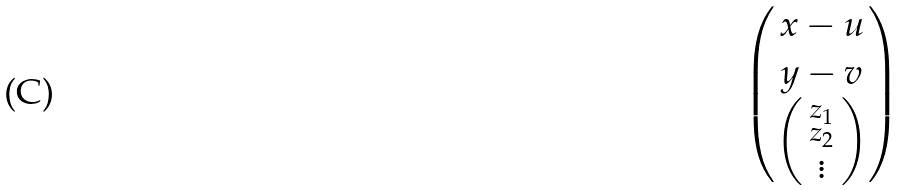Convert formula to latex. <formula><loc_0><loc_0><loc_500><loc_500>\begin{pmatrix} x - u \\ y - v \\ \left ( \begin{smallmatrix} z _ { 1 } \\ z _ { 2 } \\ \vdots \end{smallmatrix} \right ) \end{pmatrix}</formula> 